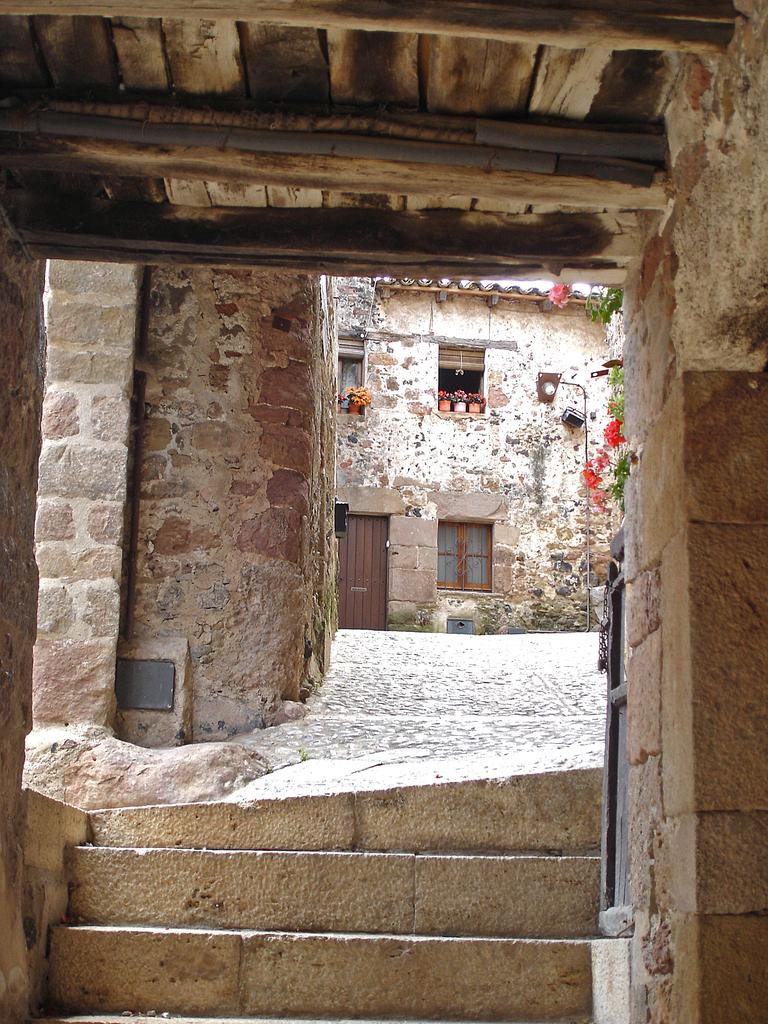What type of structure is visible in the image? There is a building in the image. What features can be seen on the building? The building has windows and a door. What architectural element is present at the bottom of the building? There are steps at the bottom of the building. What is located to the left of the building? There is a wall to the left of the building. What material is used for the roof of the building? The roof of the building is made up of wood. What type of string is used to hold the mountain in place in the image? There is no mountain present in the image, and therefore no string is needed to hold it in place. 